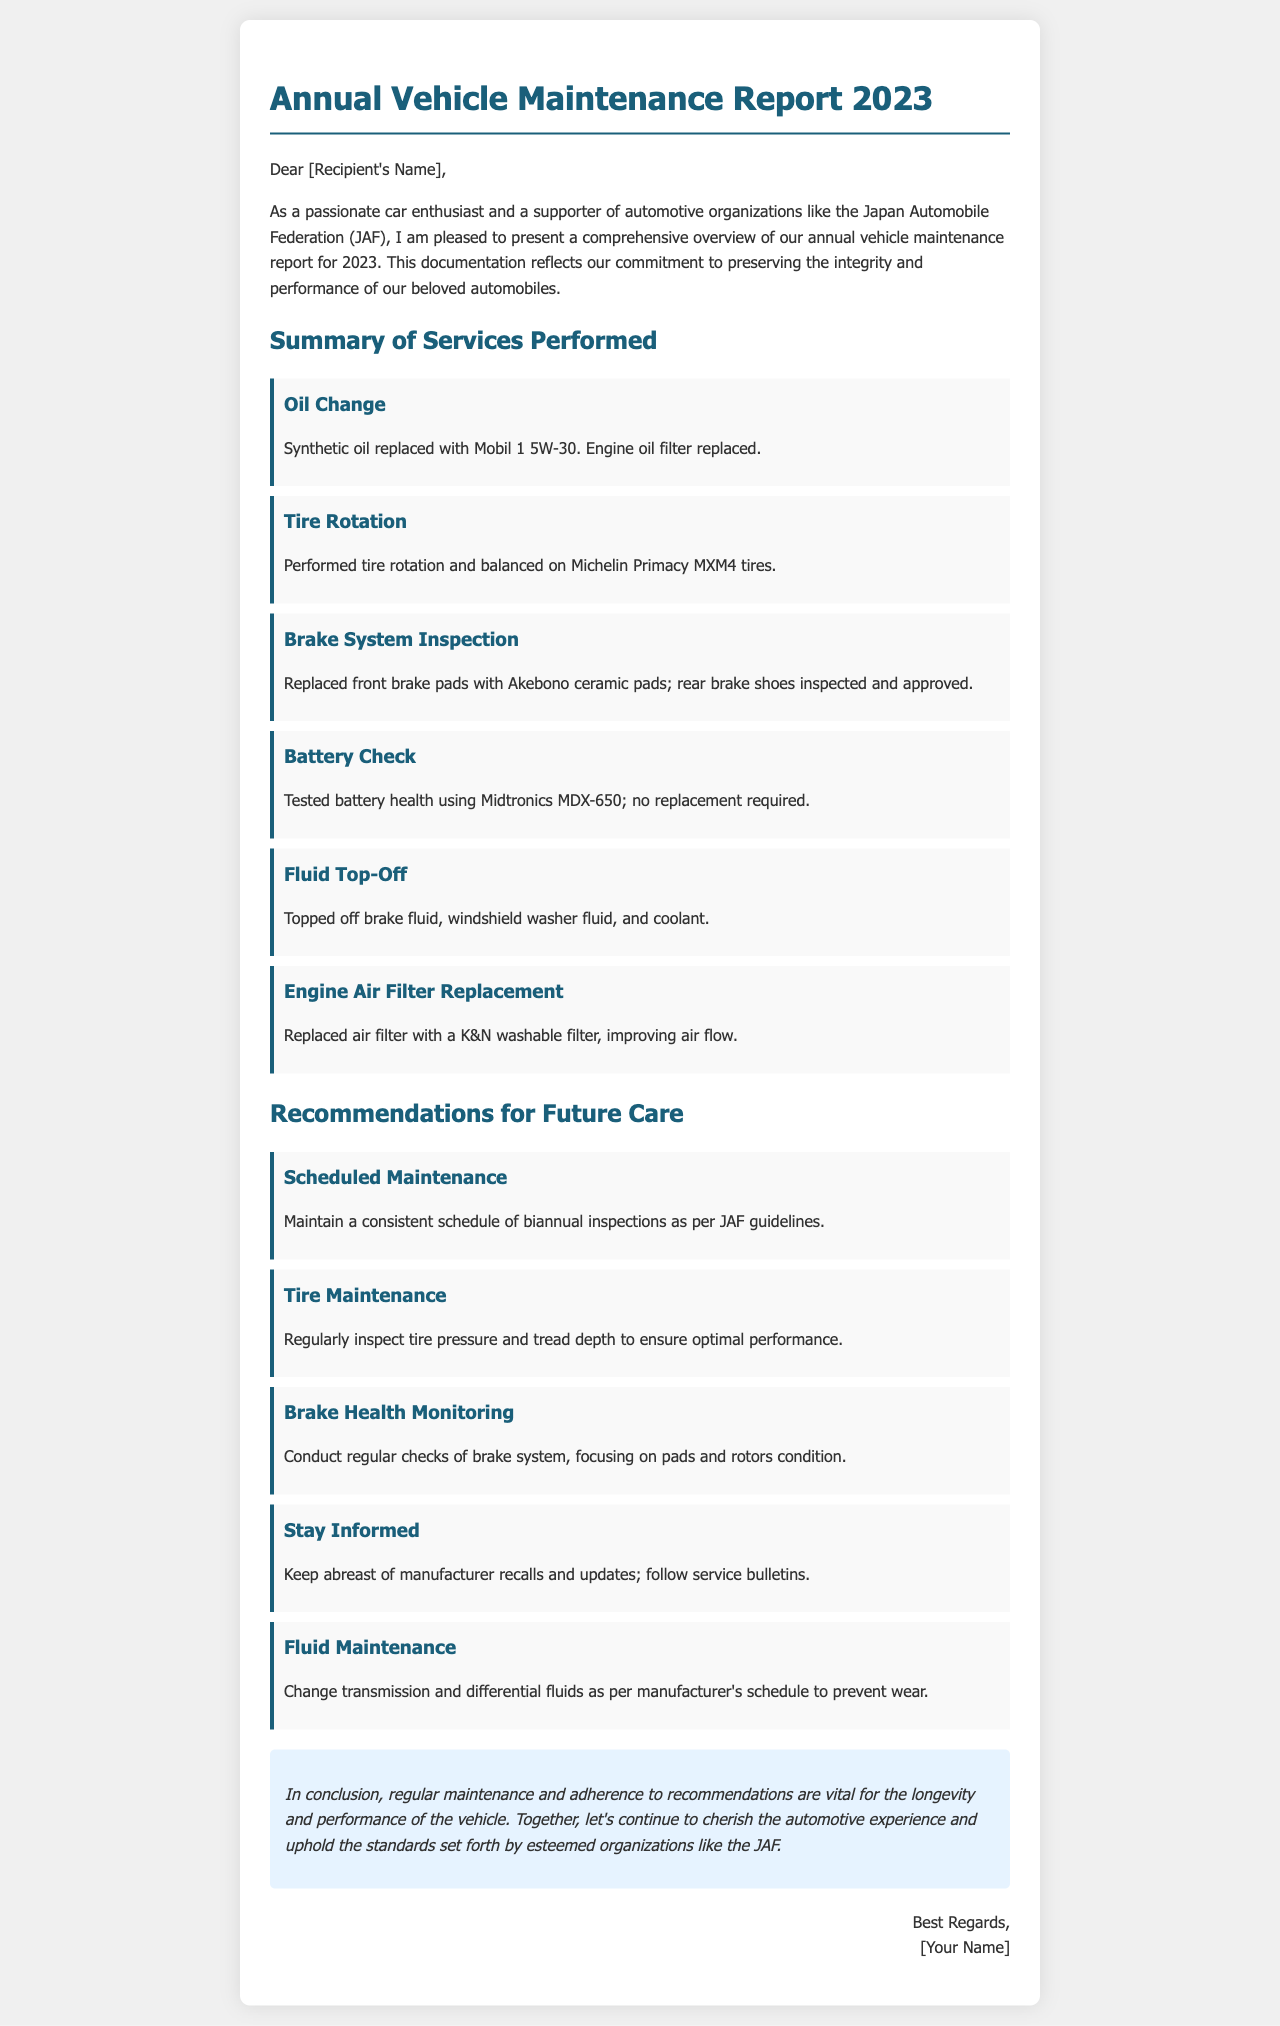What is the title of the document? The title is clearly mentioned at the top of the document, signifying its main focus.
Answer: Annual Vehicle Maintenance Report 2023 Who is the intended recipient of the letter? The recipient's name is noted as [Recipient's Name], which is a placeholder for the actual name.
Answer: [Recipient's Name] What type of oil was used for the oil change? The document specifies the brand and type of oil used during the service performed.
Answer: Mobil 1 5W-30 How many recommendations are provided for future care? The recommendations section lists a series of items that are part of the maintenance advice.
Answer: Five What should be monitored for brake health? The document advises specific components that need to be checked regarding the brake system.
Answer: Pads and rotors condition What fluid was topped off along with others during maintenance? The summary includes a variety of fluids that were replenished during the service described.
Answer: Windshield washer fluid What kind of air filter was installed? The report details the type of air filter that was replaced during maintenance.
Answer: K&N washable filter How often are biannual inspections recommended? The recommendations suggest a schedule based on guidelines, indicating frequency of checks.
Answer: Biannual What is the tone of the conclusion regarding vehicle maintenance? The concluding remarks summarize the document's overall message about ongoing vehicle care.
Answer: Vital for longevity and performance 